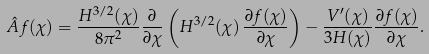Convert formula to latex. <formula><loc_0><loc_0><loc_500><loc_500>\hat { A } f ( \chi ) = \frac { H ^ { 3 / 2 } ( \chi ) } { 8 \pi ^ { 2 } } \frac { \partial } { \partial \chi } \left ( H ^ { 3 / 2 } ( \chi ) \, \frac { \partial f ( \chi ) } { \partial \chi } \right ) - \frac { V ^ { \prime } ( \chi ) } { 3 H ( \chi ) } \frac { \partial f ( \chi ) } { \partial \chi } .</formula> 